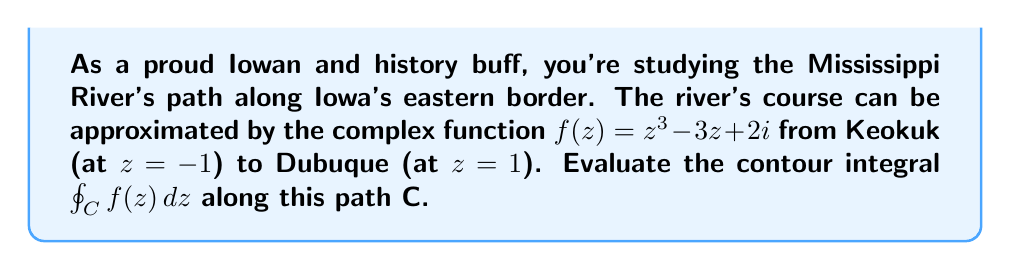Provide a solution to this math problem. To solve this problem, we'll use the following steps:

1) First, we need to recognize that the given function $f(z) = z^3 - 3z + 2i$ is analytic everywhere in the complex plane. This is because it's a polynomial function with complex coefficients.

2) The path C is a straight line from $z=-1$ to $z=1$ along the real axis, representing the Mississippi River's approximated path along Iowa's eastern border.

3) Since $f(z)$ is analytic everywhere, and the path C forms a simple closed curve (when we consider the return path along the real axis), we can apply Cauchy's Integral Theorem.

4) Cauchy's Integral Theorem states that if $f(z)$ is analytic everywhere inside and on a simple closed contour C, then:

   $$\oint_C f(z) dz = 0$$

5) In our case, $f(z)$ is indeed analytic everywhere, including inside and on the contour formed by the path from $-1$ to $1$ along the real axis and back.

6) Therefore, we can directly conclude that the contour integral is zero.

This result tells us that the net "flow" of the function around this closed path is zero, which could be interpreted in the context of the Mississippi River as the net change in some property (like elevation or flow rate) being zero when we consider the complete circuit.
Answer: $$\oint_C f(z) dz = 0$$ 